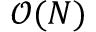<formula> <loc_0><loc_0><loc_500><loc_500>\mathcal { O } ( N )</formula> 